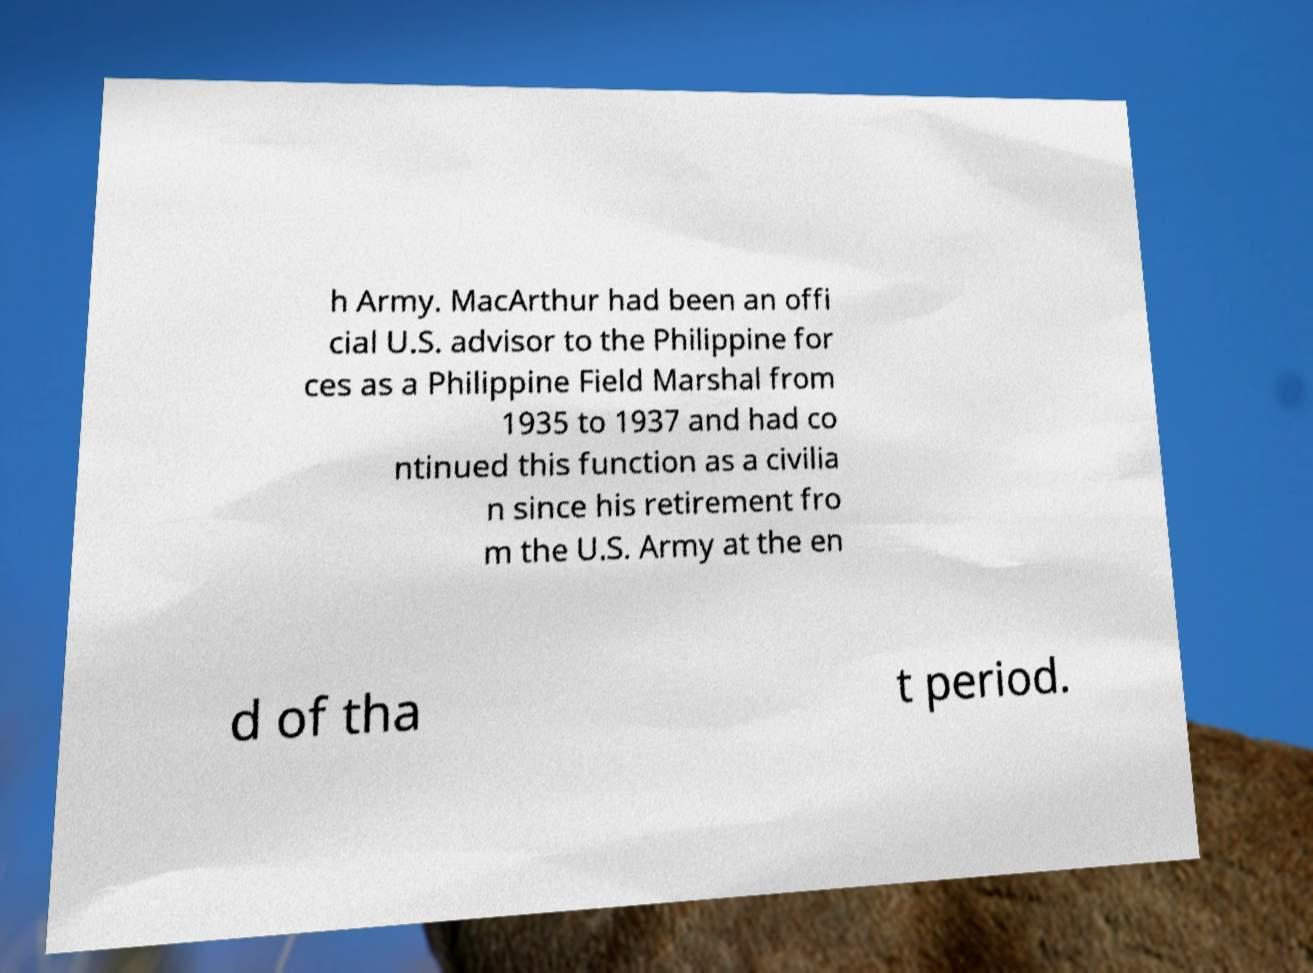Please read and relay the text visible in this image. What does it say? h Army. MacArthur had been an offi cial U.S. advisor to the Philippine for ces as a Philippine Field Marshal from 1935 to 1937 and had co ntinued this function as a civilia n since his retirement fro m the U.S. Army at the en d of tha t period. 